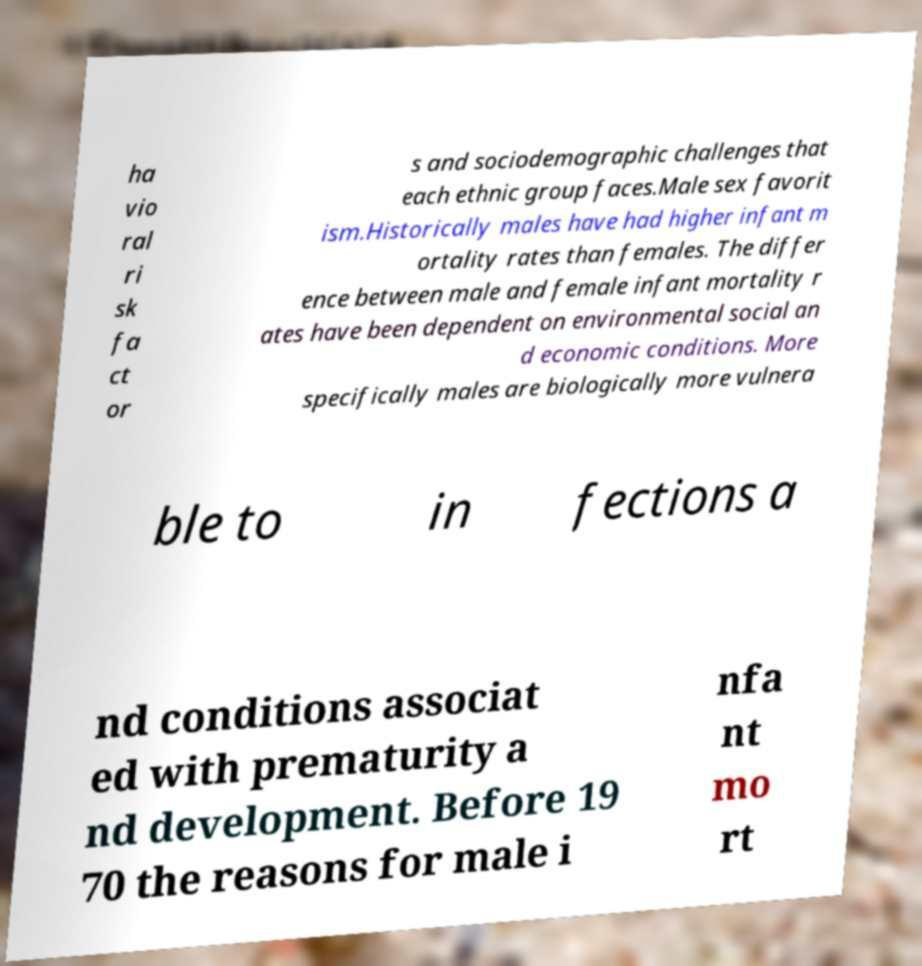What messages or text are displayed in this image? I need them in a readable, typed format. ha vio ral ri sk fa ct or s and sociodemographic challenges that each ethnic group faces.Male sex favorit ism.Historically males have had higher infant m ortality rates than females. The differ ence between male and female infant mortality r ates have been dependent on environmental social an d economic conditions. More specifically males are biologically more vulnera ble to in fections a nd conditions associat ed with prematurity a nd development. Before 19 70 the reasons for male i nfa nt mo rt 